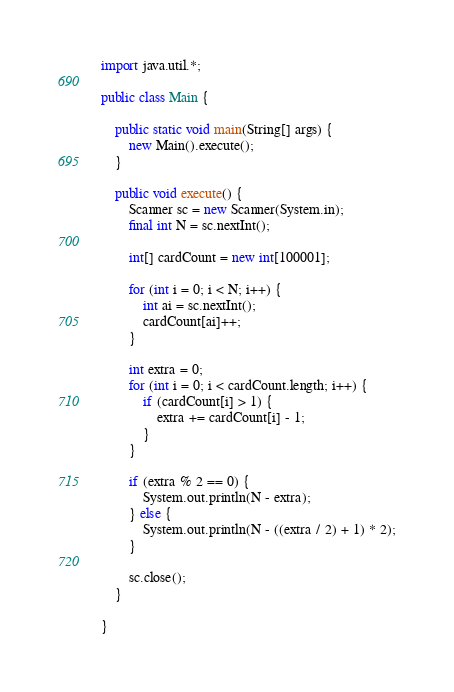Convert code to text. <code><loc_0><loc_0><loc_500><loc_500><_Java_>import java.util.*;

public class Main {

	public static void main(String[] args) {
		new Main().execute();
	}

	public void execute() {
		Scanner sc = new Scanner(System.in);
		final int N = sc.nextInt();

		int[] cardCount = new int[100001];

		for (int i = 0; i < N; i++) {
			int ai = sc.nextInt();
			cardCount[ai]++;
		}

		int extra = 0;
		for (int i = 0; i < cardCount.length; i++) {
			if (cardCount[i] > 1) {
				extra += cardCount[i] - 1;
			}
		}

		if (extra % 2 == 0) {
			System.out.println(N - extra);
		} else {
			System.out.println(N - ((extra / 2) + 1) * 2);
		}

		sc.close();
	}

}
</code> 